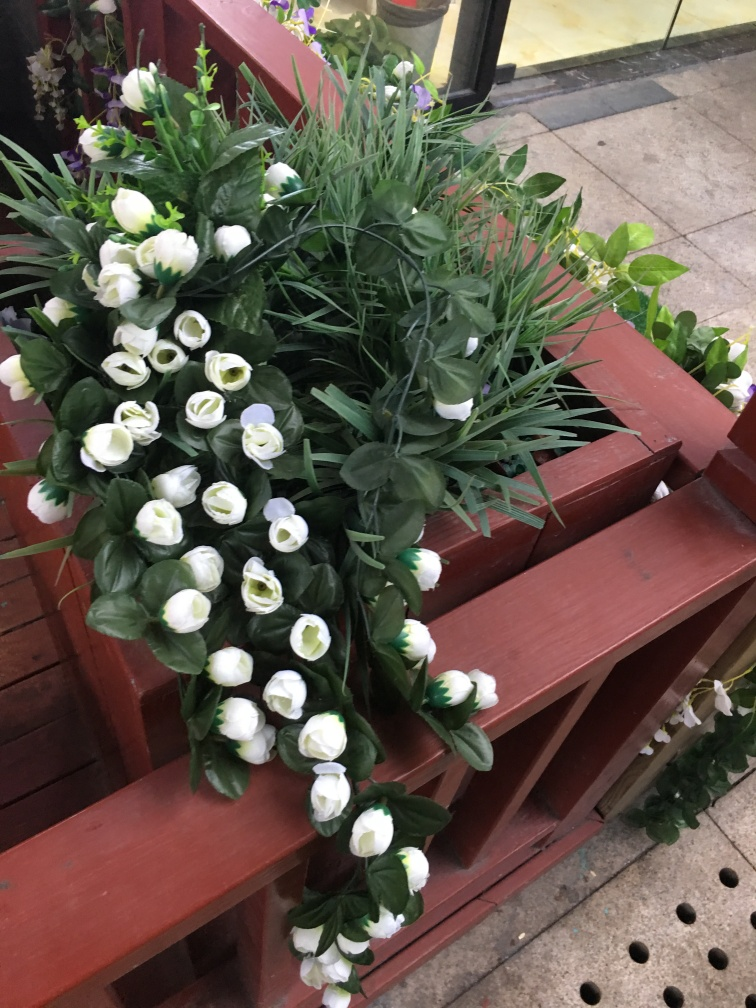What is the main subject of the image?
A. A person
B. An animal
C. A plant
Answer with the option's letter from the given choices directly.
 C. 